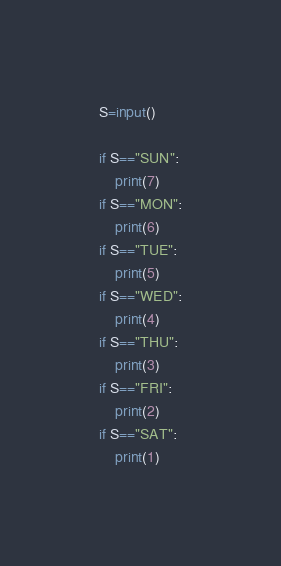Convert code to text. <code><loc_0><loc_0><loc_500><loc_500><_Python_>S=input()

if S=="SUN":
    print(7)
if S=="MON":
    print(6)
if S=="TUE":
    print(5)
if S=="WED":
    print(4)
if S=="THU":
    print(3)
if S=="FRI":
    print(2)
if S=="SAT":
    print(1)
</code> 